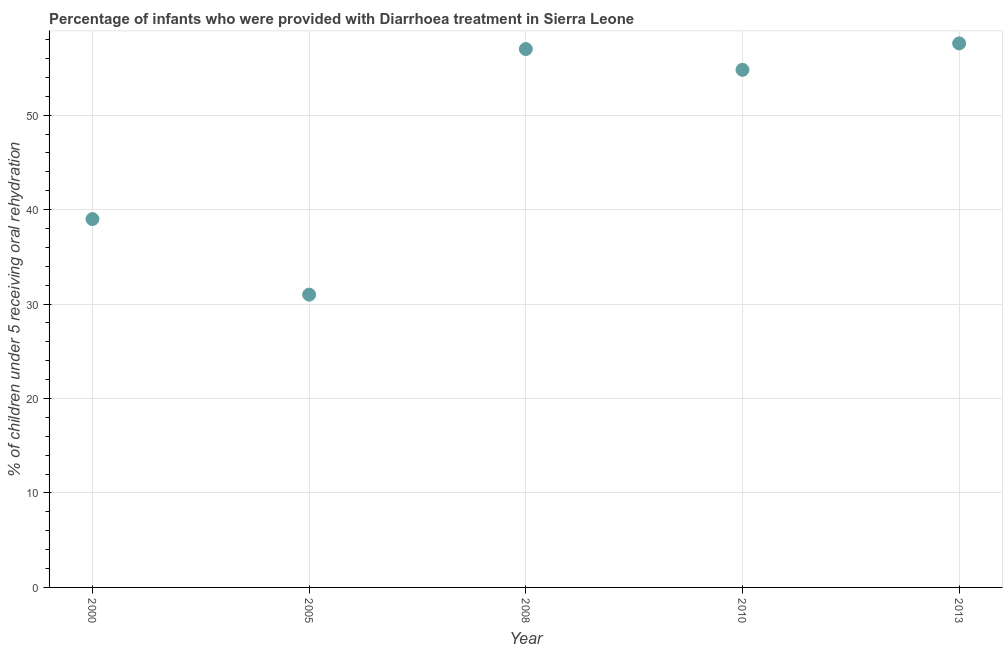What is the percentage of children who were provided with treatment diarrhoea in 2005?
Provide a succinct answer. 31. Across all years, what is the maximum percentage of children who were provided with treatment diarrhoea?
Ensure brevity in your answer.  57.6. Across all years, what is the minimum percentage of children who were provided with treatment diarrhoea?
Give a very brief answer. 31. In which year was the percentage of children who were provided with treatment diarrhoea maximum?
Keep it short and to the point. 2013. What is the sum of the percentage of children who were provided with treatment diarrhoea?
Your answer should be compact. 239.4. What is the difference between the percentage of children who were provided with treatment diarrhoea in 2005 and 2008?
Make the answer very short. -26. What is the average percentage of children who were provided with treatment diarrhoea per year?
Provide a short and direct response. 47.88. What is the median percentage of children who were provided with treatment diarrhoea?
Offer a terse response. 54.8. Do a majority of the years between 2013 and 2008 (inclusive) have percentage of children who were provided with treatment diarrhoea greater than 34 %?
Your answer should be compact. No. What is the ratio of the percentage of children who were provided with treatment diarrhoea in 2000 to that in 2005?
Give a very brief answer. 1.26. Is the percentage of children who were provided with treatment diarrhoea in 2005 less than that in 2010?
Ensure brevity in your answer.  Yes. Is the difference between the percentage of children who were provided with treatment diarrhoea in 2000 and 2008 greater than the difference between any two years?
Keep it short and to the point. No. What is the difference between the highest and the second highest percentage of children who were provided with treatment diarrhoea?
Your answer should be very brief. 0.6. Is the sum of the percentage of children who were provided with treatment diarrhoea in 2000 and 2008 greater than the maximum percentage of children who were provided with treatment diarrhoea across all years?
Give a very brief answer. Yes. What is the difference between the highest and the lowest percentage of children who were provided with treatment diarrhoea?
Provide a short and direct response. 26.6. How many dotlines are there?
Your response must be concise. 1. Are the values on the major ticks of Y-axis written in scientific E-notation?
Give a very brief answer. No. What is the title of the graph?
Give a very brief answer. Percentage of infants who were provided with Diarrhoea treatment in Sierra Leone. What is the label or title of the Y-axis?
Make the answer very short. % of children under 5 receiving oral rehydration. What is the % of children under 5 receiving oral rehydration in 2000?
Provide a short and direct response. 39. What is the % of children under 5 receiving oral rehydration in 2010?
Offer a terse response. 54.8. What is the % of children under 5 receiving oral rehydration in 2013?
Provide a succinct answer. 57.6. What is the difference between the % of children under 5 receiving oral rehydration in 2000 and 2008?
Offer a terse response. -18. What is the difference between the % of children under 5 receiving oral rehydration in 2000 and 2010?
Offer a very short reply. -15.8. What is the difference between the % of children under 5 receiving oral rehydration in 2000 and 2013?
Make the answer very short. -18.6. What is the difference between the % of children under 5 receiving oral rehydration in 2005 and 2008?
Your response must be concise. -26. What is the difference between the % of children under 5 receiving oral rehydration in 2005 and 2010?
Your answer should be compact. -23.8. What is the difference between the % of children under 5 receiving oral rehydration in 2005 and 2013?
Your response must be concise. -26.6. What is the ratio of the % of children under 5 receiving oral rehydration in 2000 to that in 2005?
Provide a succinct answer. 1.26. What is the ratio of the % of children under 5 receiving oral rehydration in 2000 to that in 2008?
Your response must be concise. 0.68. What is the ratio of the % of children under 5 receiving oral rehydration in 2000 to that in 2010?
Your response must be concise. 0.71. What is the ratio of the % of children under 5 receiving oral rehydration in 2000 to that in 2013?
Offer a terse response. 0.68. What is the ratio of the % of children under 5 receiving oral rehydration in 2005 to that in 2008?
Your answer should be very brief. 0.54. What is the ratio of the % of children under 5 receiving oral rehydration in 2005 to that in 2010?
Your response must be concise. 0.57. What is the ratio of the % of children under 5 receiving oral rehydration in 2005 to that in 2013?
Offer a terse response. 0.54. What is the ratio of the % of children under 5 receiving oral rehydration in 2008 to that in 2013?
Your answer should be compact. 0.99. What is the ratio of the % of children under 5 receiving oral rehydration in 2010 to that in 2013?
Provide a succinct answer. 0.95. 